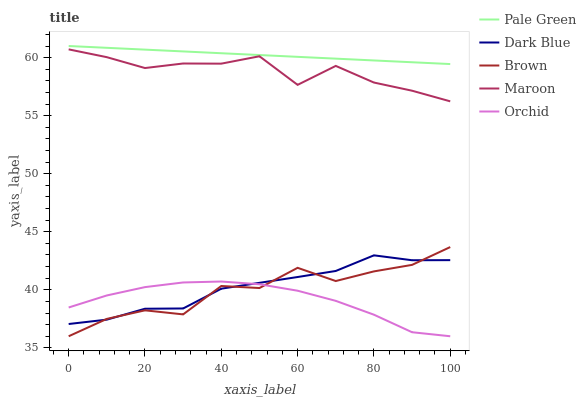Does Orchid have the minimum area under the curve?
Answer yes or no. Yes. Does Dark Blue have the minimum area under the curve?
Answer yes or no. No. Does Dark Blue have the maximum area under the curve?
Answer yes or no. No. Is Dark Blue the smoothest?
Answer yes or no. No. Is Dark Blue the roughest?
Answer yes or no. No. Does Dark Blue have the lowest value?
Answer yes or no. No. Does Dark Blue have the highest value?
Answer yes or no. No. Is Orchid less than Maroon?
Answer yes or no. Yes. Is Pale Green greater than Dark Blue?
Answer yes or no. Yes. Does Orchid intersect Maroon?
Answer yes or no. No. 